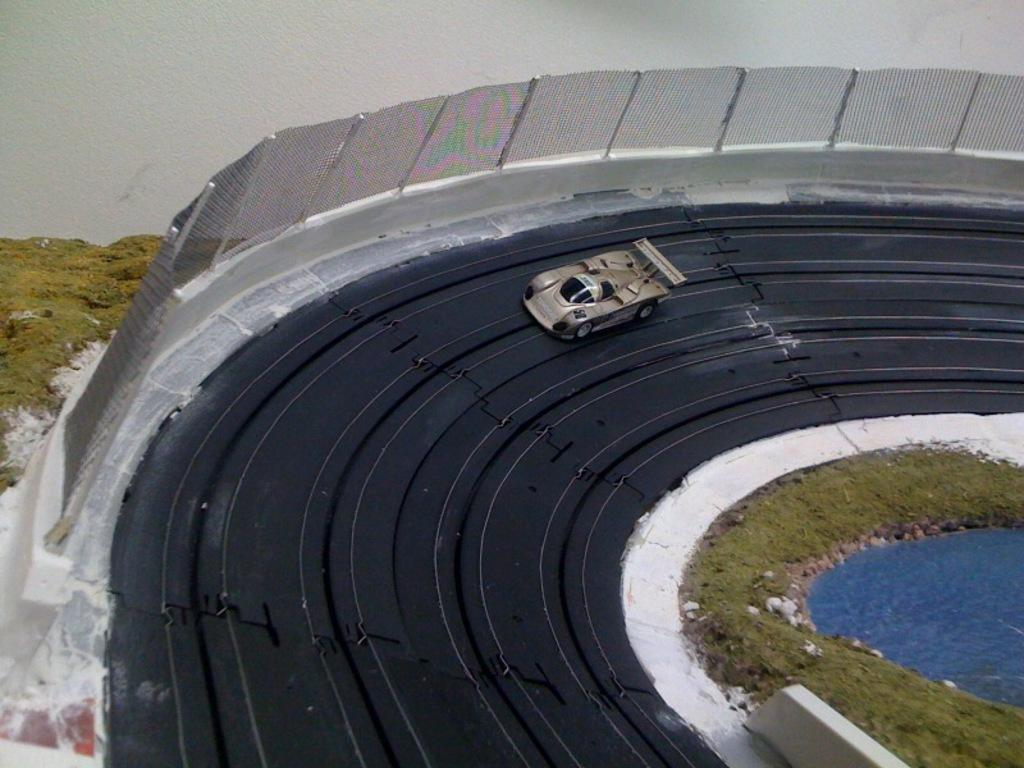What is the main object on the black color board in the image? There is a toy car on a black color board in the image. What type of natural environment is depicted in the image? There is grass in the image, which suggests a natural setting. What other objects can be seen in the image? There are waterstones and a wire fence in the image. How many geese are sitting on the toy car in the image? There are no geese present in the image; it features a toy car on a black color board, grass, waterstones, and a wire fence. 